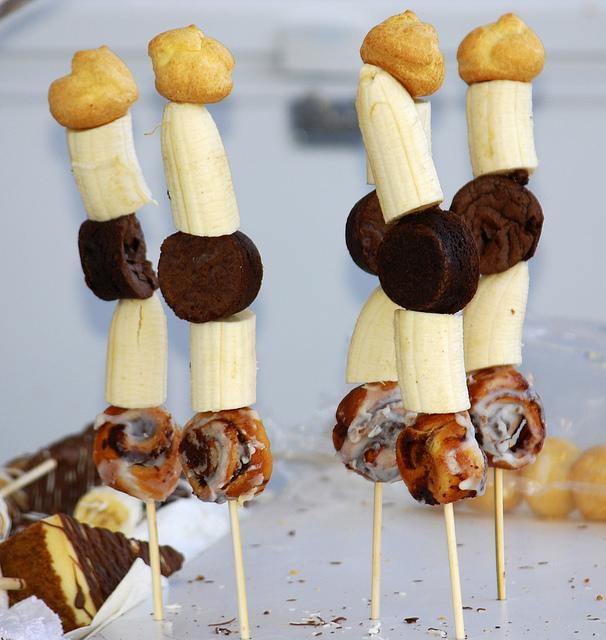What fruit is on the stick?
Give a very brief answer. Banana. How was this made?
Short answer required. I don't know. Is this food sweet or savory?
Write a very short answer. Sweet. 